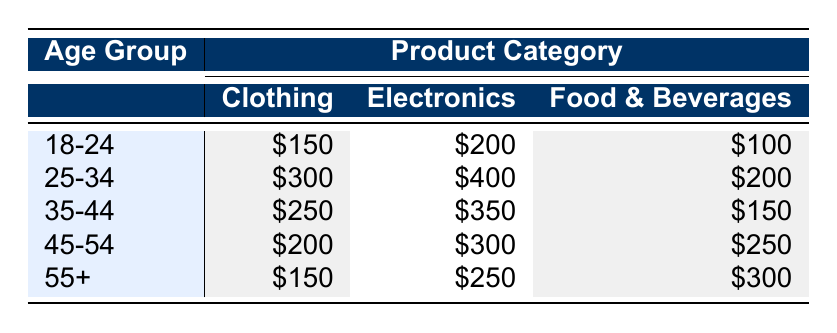What is the total spending on Clothing by the age group 25-34? For the age group 25-34, the spending on Clothing is $300. There are no other values to add since we're only interested in Clothing for this specific age group.
Answer: 300 Which product category has the highest spending for the age group 18-24? In the age group 18-24, the spending is $150 for Clothing, $200 for Electronics, and $100 for Food & Beverages. The highest spending among these is $200 on Electronics.
Answer: 200 Is the spending on Food & Beverages higher for the age group 55+ compared to the age group 25-34? For age group 55+, the spending on Food & Beverages is $300, while for age group 25-34, it is $200. Since $300 is greater than $200, the statement is true.
Answer: Yes What is the average spending across all age groups for Electronics? To find the average spending on Electronics, we sum the values: $200 (18-24) + $400 (25-34) + $350 (35-44) + $300 (45-54) + $250 (55+) = $1500. There are 5 age groups, so we divide by 5: $1500 / 5 = $300.
Answer: 300 Do the age groups 45-54 and 35-44 spend the same amount on Clothing? The spending on Clothing for age group 45-54 is $200, while for age group 35-44, it is $250. Since these amounts are different, the statement is false.
Answer: No What is the total spending on Food & Beverages for all age groups? The total spending on Food & Beverages is calculated by adding together all values: $100 (18-24) + $200 (25-34) + $150 (35-44) + $250 (45-54) + $300 (55+) = $1000.
Answer: 1000 Which age group spends $250 on Electronics? Upon reviewing the table, the spending of $250 on Electronics is associated with the age group 55+.
Answer: 55+ Compare the total spending on Clothing across all age groups to that of Electronics. Which category is higher? The total spending on Clothing is $150 (18-24) + $300 (25-34) + $250 (35-44) + $200 (45-54) + $150 (55+) = $1050. For Electronics, it is $200 (18-24) + $400 (25-34) + $350 (35-44) + $300 (45-54) + $250 (55+) = $1500. Since $1500 (Electronics) is greater than $1050 (Clothing), the spending on Electronics is higher.
Answer: Electronics 